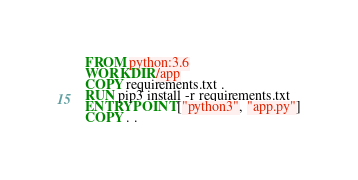<code> <loc_0><loc_0><loc_500><loc_500><_Dockerfile_>FROM python:3.6
WORKDIR /app
COPY requirements.txt .
RUN pip3 install -r requirements.txt
ENTRYPOINT ["python3", "app.py"]
COPY . .


</code> 